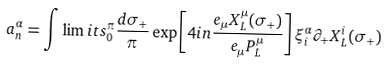Convert formula to latex. <formula><loc_0><loc_0><loc_500><loc_500>a ^ { \alpha } _ { n } = \int \lim i t s _ { 0 } ^ { \pi } \frac { d \sigma _ { + } } { \pi } \exp \left [ 4 i n \frac { e _ { \mu } X ^ { \mu } _ { L } ( \sigma _ { + } ) } { e _ { \mu } P ^ { \mu } _ { L } } \right ] \xi ^ { \alpha } _ { i } \partial _ { + } X ^ { i } _ { L } ( \sigma _ { + } )</formula> 